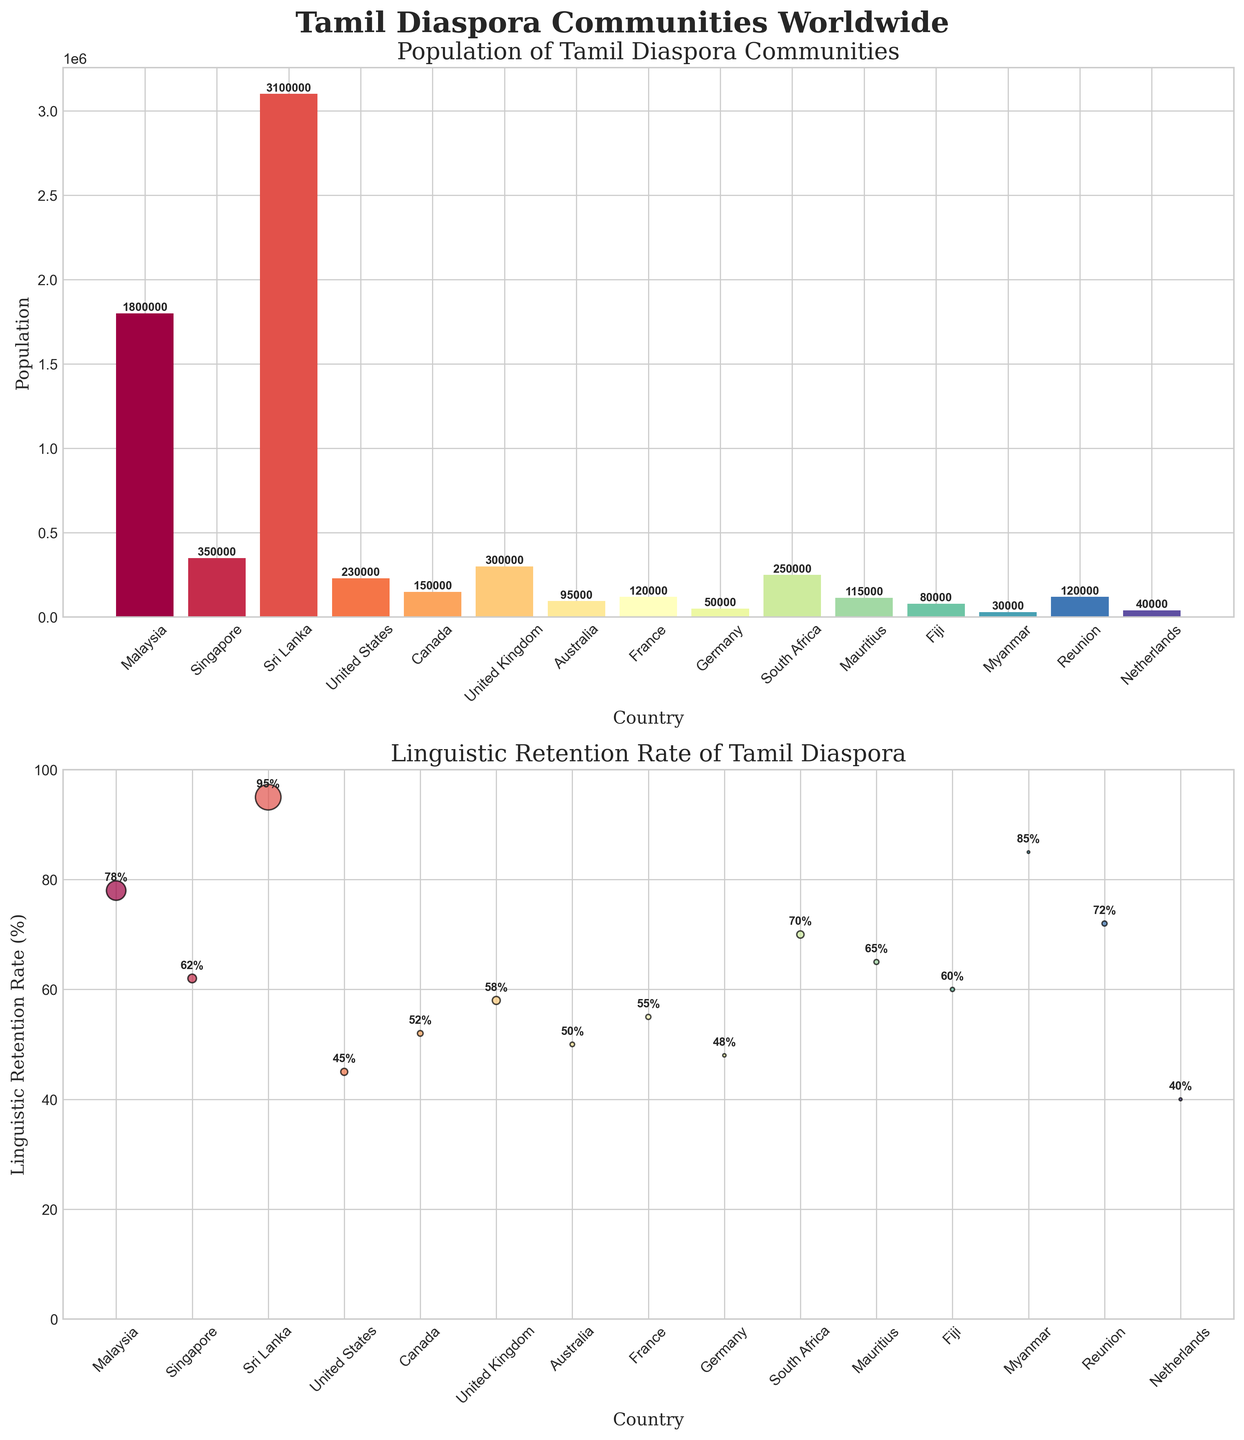Which country has the highest population of Tamil diaspora? The bar chart in the top subplot shows Sri Lanka with the highest population bar, reaching up to 3,100,000.
Answer: Sri Lanka What is the linguistic retention rate in Malaysia? The scatter plot in the bottom subplot indicates that Malaysia has a linguistic retention rate of 78%, marked by its position on the y-axis.
Answer: 78% Which country has the lowest linguistic retention rate? By looking at the scatter plot, the Netherlands has the lowest data point on the y-axis with a retention rate of 40%.
Answer: Netherlands How many countries have a population of Tamil diaspora over 1,000,000? By checking the population bars in the top subplot, Sri Lanka (3,100,000) and Malaysia (1,800,000) are the only two with populations over 1,000,000.
Answer: 2 What's the difference in linguistic retention rates between the United States and Canada? According to the scatter plot, the retention rate for the United States is 45% and for Canada it is 52%. The difference is 52 - 45 = 7%.
Answer: 7% Which countries have a linguistic retention rate above 80%? The scatter plot shows Sri Lanka (95%), Myanmar (85%), and Malaysia (78%). Although Malaysia is close, only Sri Lanka and Myanmar are above 80%.
Answer: Sri Lanka, Myanmar How does the population size relate to the scatter plot markers' size? The markers in the scatter plot are proportional to population size; larger populations have bigger markers, like Sri Lanka and Malaysia.
Answer: Proportional to population size Which country seems to have a high linguistic retention rate but a relatively small population? Myanmar, as indicated by a small marker but a high position on the y-axis (85%) in the scatter plot.
Answer: Myanmar Which regions can you identify as having significant Tamil diaspora communities but moderate retention rates? The bar chart and scatter plot show that the United States, Canada, and the United Kingdom have considerable populations but moderate retention rates (45%, 52%, 58% respectively).
Answer: United States, Canada, United Kingdom 